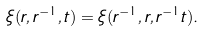Convert formula to latex. <formula><loc_0><loc_0><loc_500><loc_500>\xi ( r , r ^ { - 1 } , t ) = \xi ( r ^ { - 1 } , r , r ^ { - 1 } t ) .</formula> 